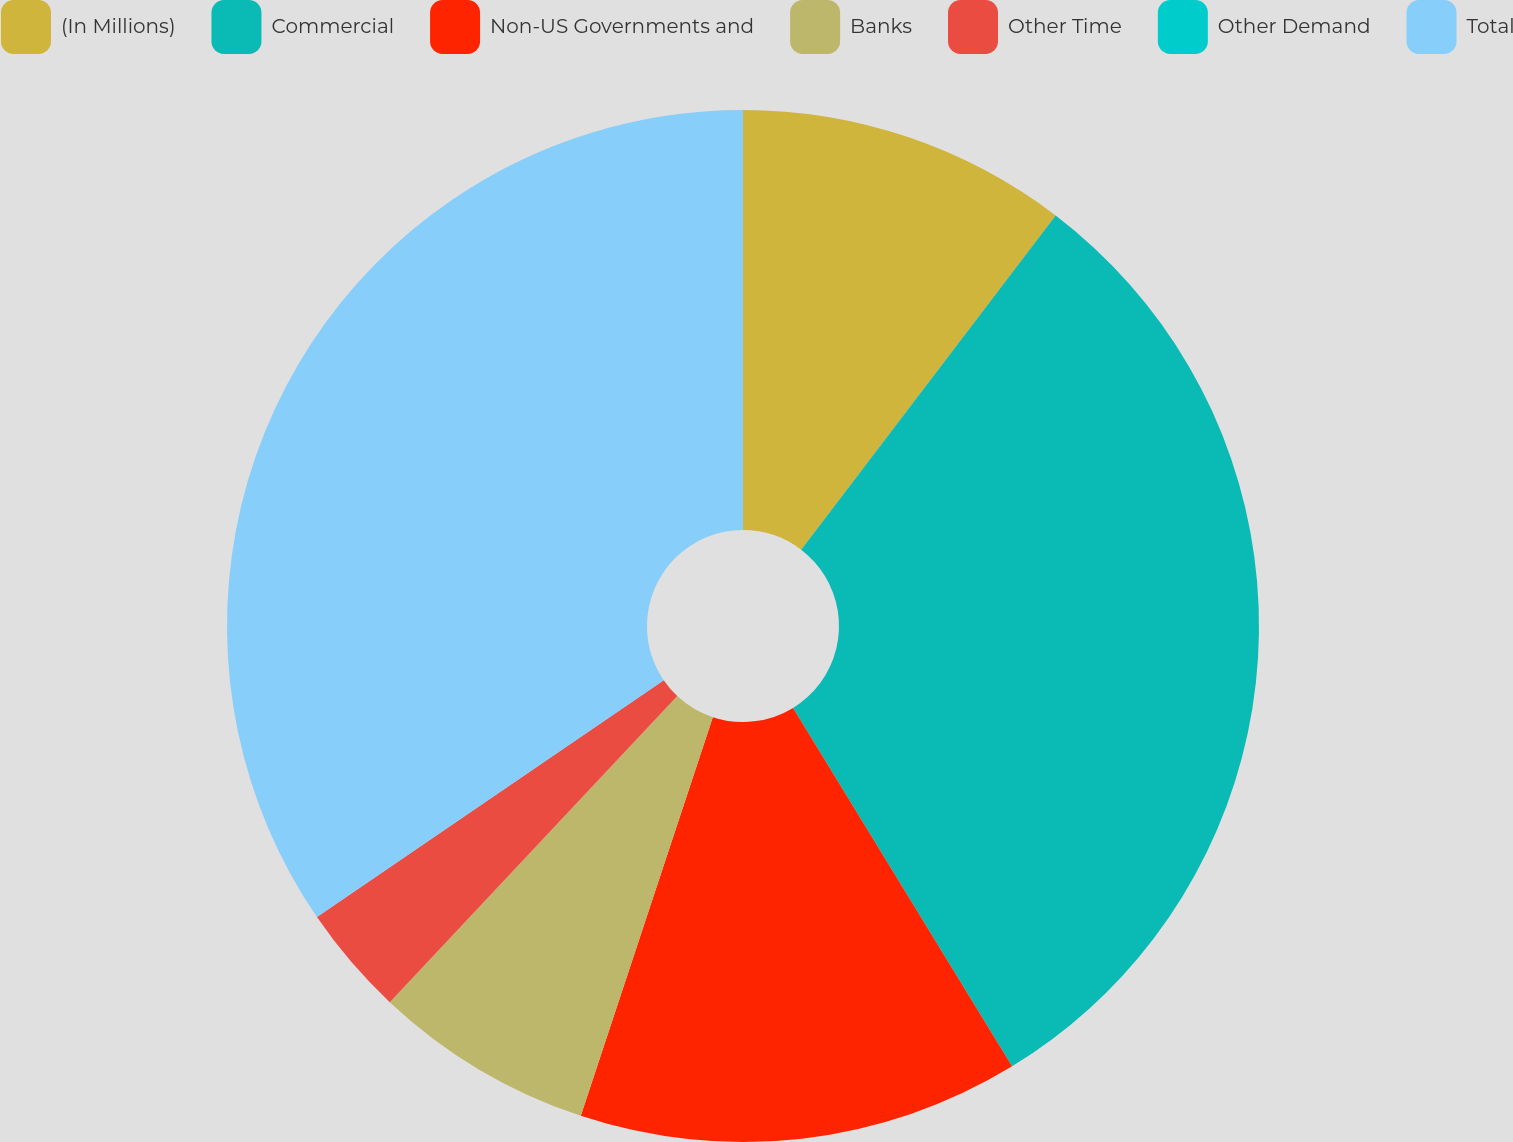Convert chart to OTSL. <chart><loc_0><loc_0><loc_500><loc_500><pie_chart><fcel>(In Millions)<fcel>Commercial<fcel>Non-US Governments and<fcel>Banks<fcel>Other Time<fcel>Other Demand<fcel>Total<nl><fcel>10.36%<fcel>30.91%<fcel>13.82%<fcel>6.91%<fcel>3.46%<fcel>0.0%<fcel>34.54%<nl></chart> 